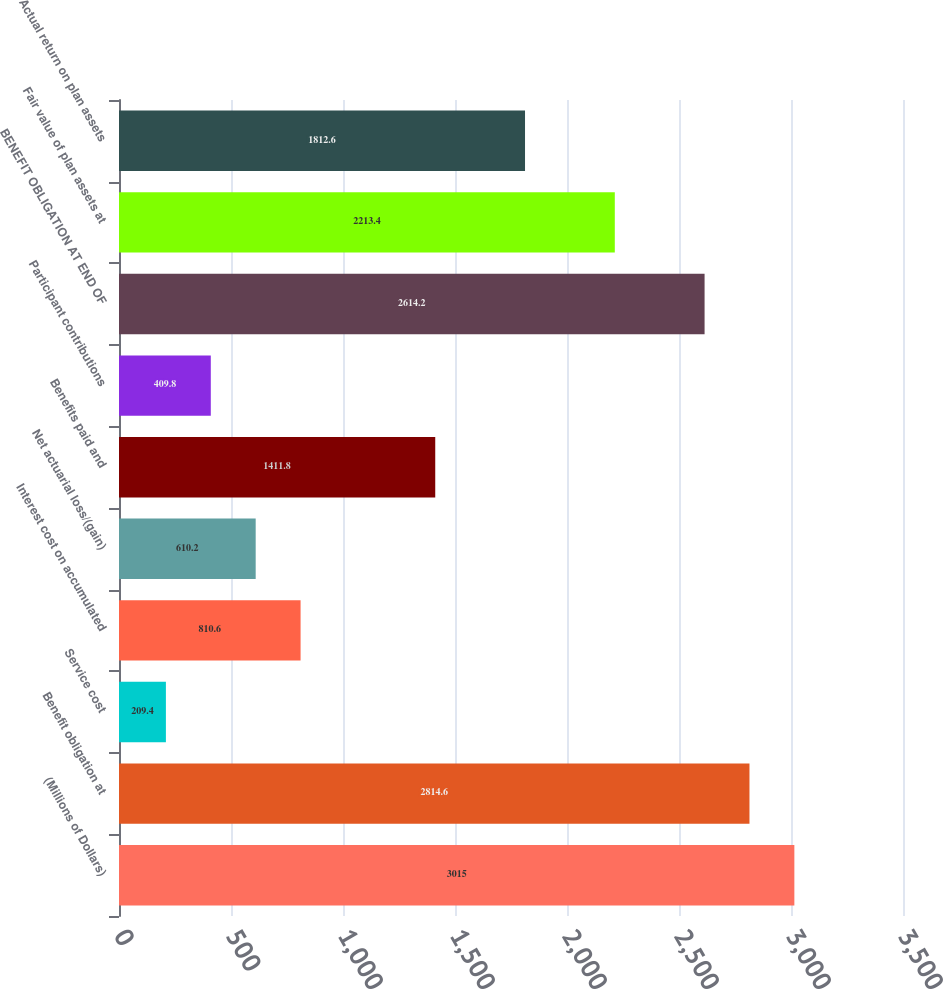Convert chart. <chart><loc_0><loc_0><loc_500><loc_500><bar_chart><fcel>(Millions of Dollars)<fcel>Benefit obligation at<fcel>Service cost<fcel>Interest cost on accumulated<fcel>Net actuarial loss/(gain)<fcel>Benefits paid and<fcel>Participant contributions<fcel>BENEFIT OBLIGATION AT END OF<fcel>Fair value of plan assets at<fcel>Actual return on plan assets<nl><fcel>3015<fcel>2814.6<fcel>209.4<fcel>810.6<fcel>610.2<fcel>1411.8<fcel>409.8<fcel>2614.2<fcel>2213.4<fcel>1812.6<nl></chart> 